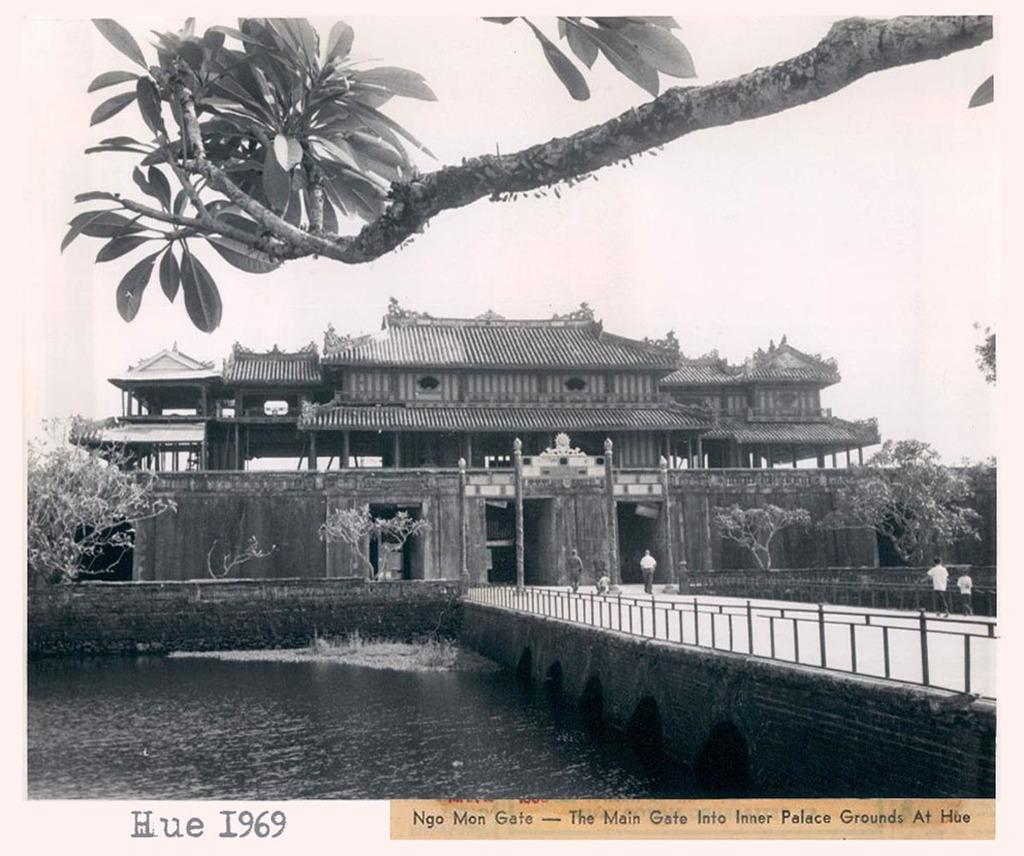What type of structure can be seen in the image? There is a building in the image. What is located in front of the building? There is a bridge in front of the building. What can be seen under the bridge? There is water under the bridge. Can you tell me how many animals are in the zoo in the image? There is no zoo present in the image, so it is not possible to determine how many animals might be there. 